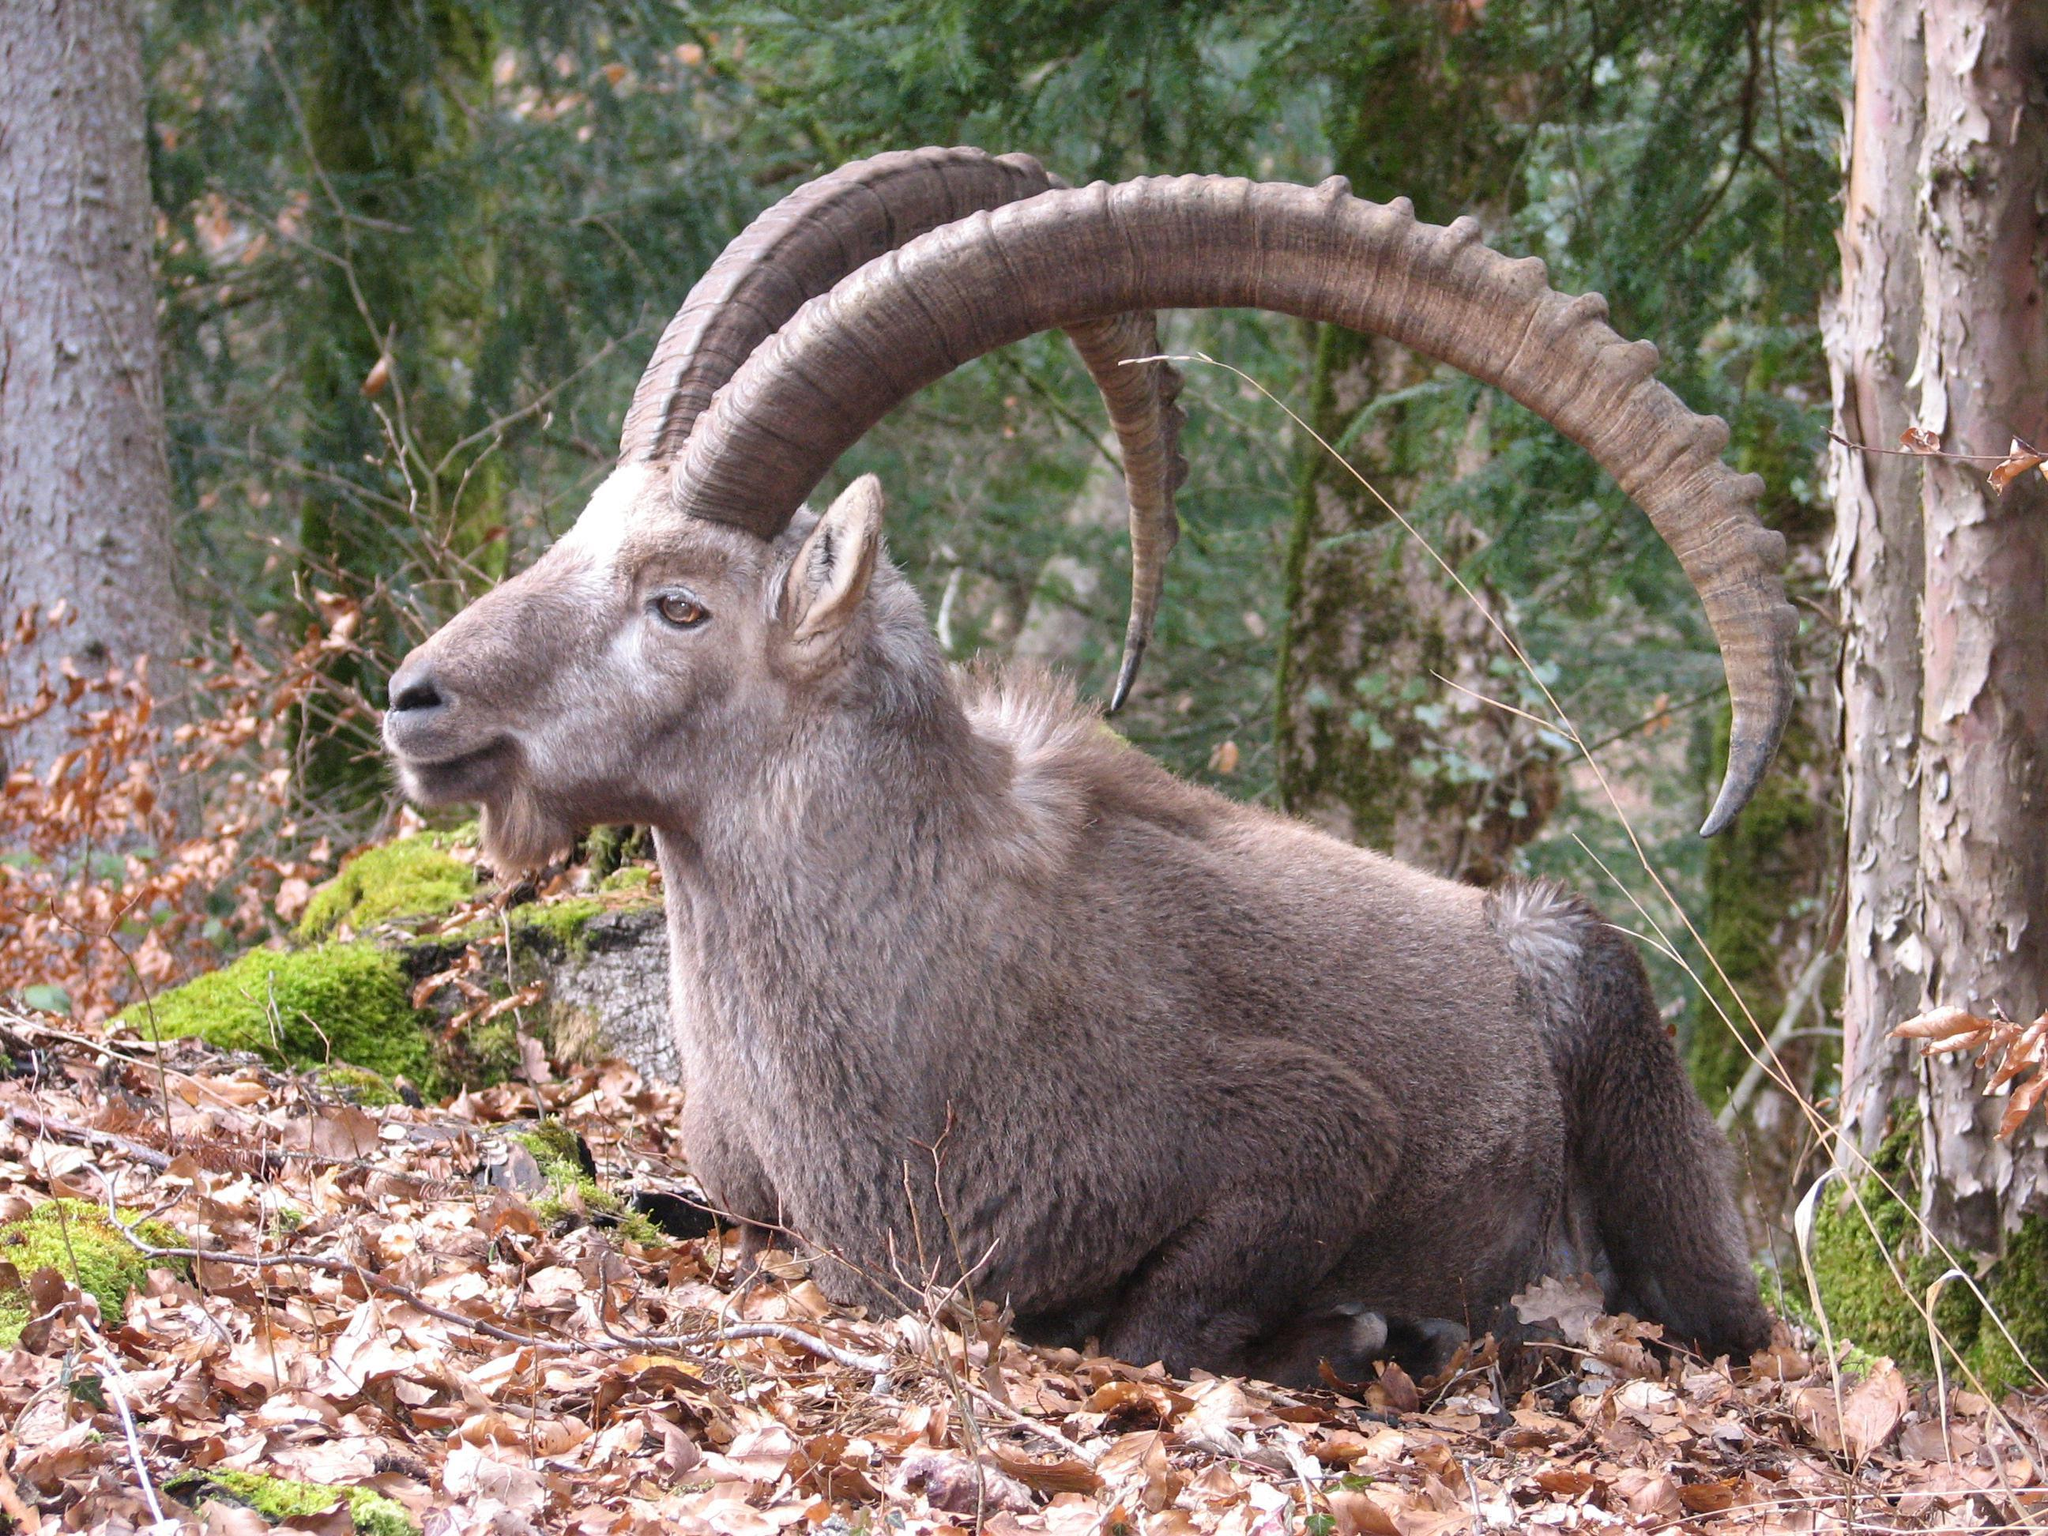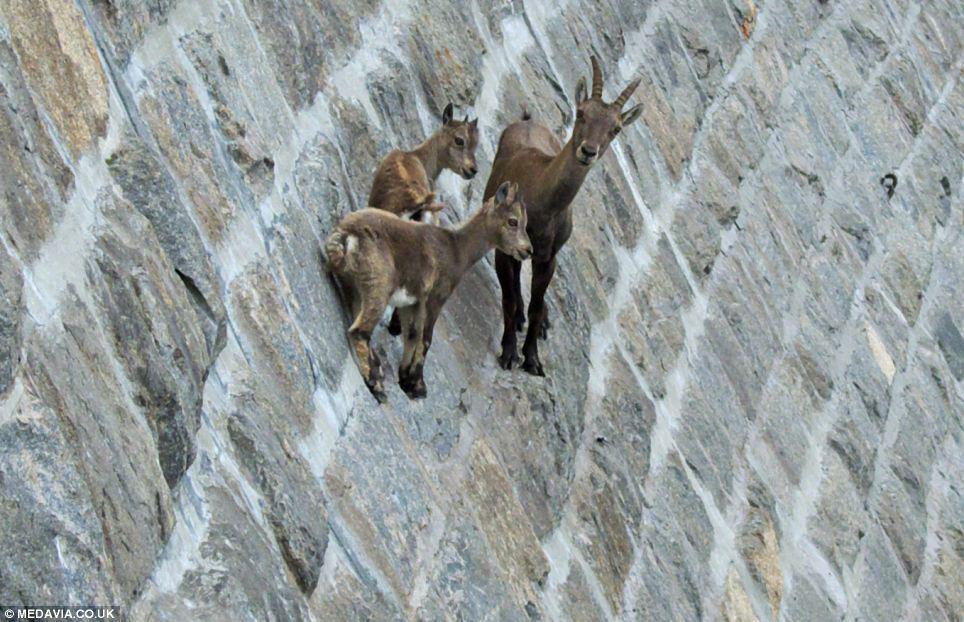The first image is the image on the left, the second image is the image on the right. Analyze the images presented: Is the assertion "One image shows multiple antelope on a sheer rock wall bare of any foliage." valid? Answer yes or no. Yes. The first image is the image on the left, the second image is the image on the right. Given the left and right images, does the statement "There are goats balancing on a very very steep cliffside." hold true? Answer yes or no. Yes. 